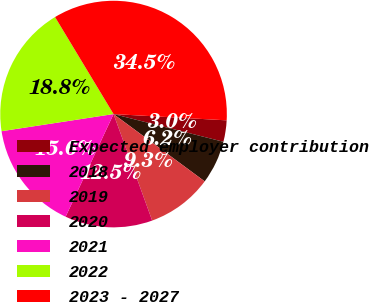<chart> <loc_0><loc_0><loc_500><loc_500><pie_chart><fcel>Expected employer contribution<fcel>2018<fcel>2019<fcel>2020<fcel>2021<fcel>2022<fcel>2023 - 2027<nl><fcel>3.05%<fcel>6.19%<fcel>9.34%<fcel>12.49%<fcel>15.63%<fcel>18.78%<fcel>34.52%<nl></chart> 